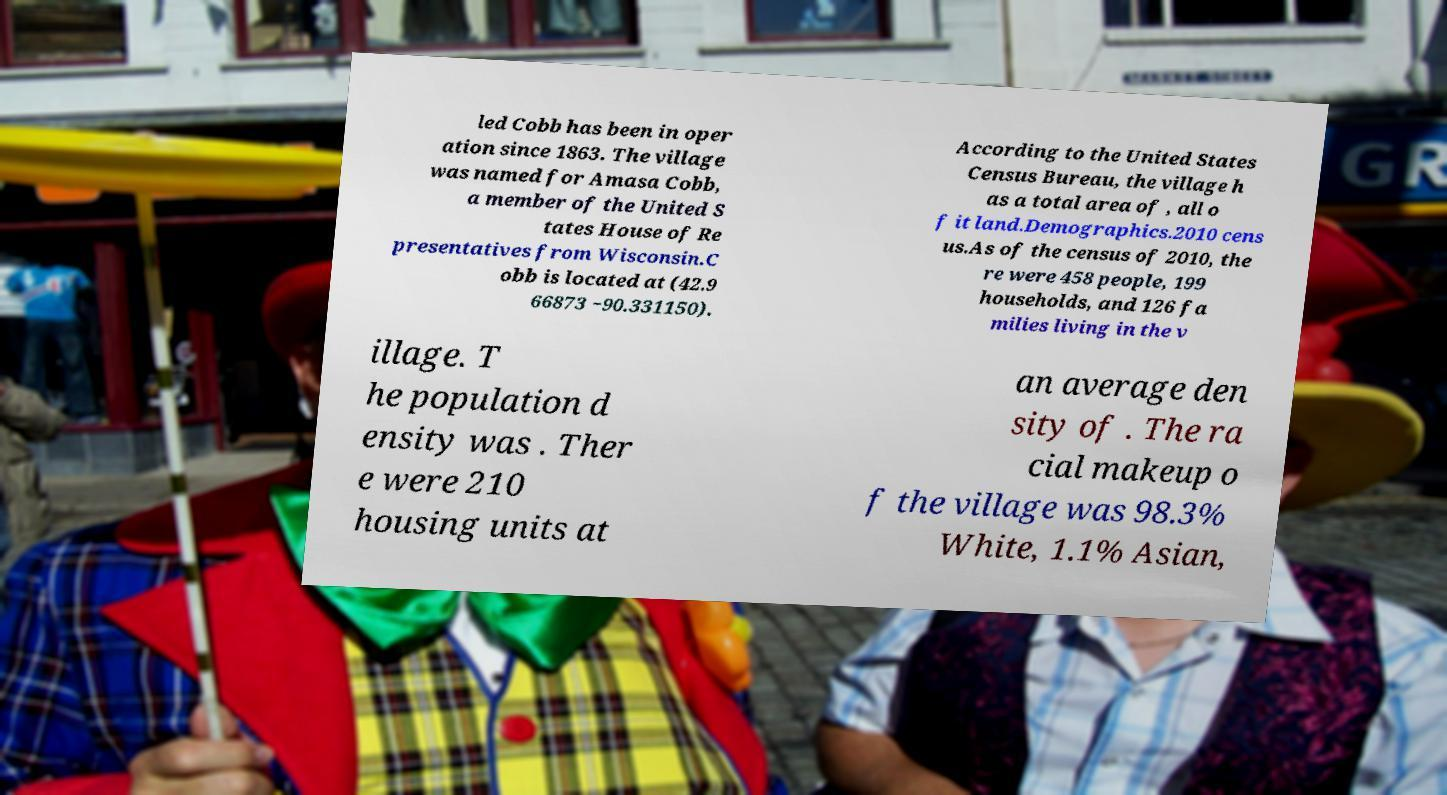I need the written content from this picture converted into text. Can you do that? led Cobb has been in oper ation since 1863. The village was named for Amasa Cobb, a member of the United S tates House of Re presentatives from Wisconsin.C obb is located at (42.9 66873 −90.331150). According to the United States Census Bureau, the village h as a total area of , all o f it land.Demographics.2010 cens us.As of the census of 2010, the re were 458 people, 199 households, and 126 fa milies living in the v illage. T he population d ensity was . Ther e were 210 housing units at an average den sity of . The ra cial makeup o f the village was 98.3% White, 1.1% Asian, 